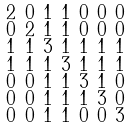<formula> <loc_0><loc_0><loc_500><loc_500>\begin{smallmatrix} 2 & 0 & 1 & 1 & 0 & 0 & 0 \\ 0 & 2 & 1 & 1 & 0 & 0 & 0 \\ 1 & 1 & 3 & 1 & 1 & 1 & 1 \\ 1 & 1 & 1 & 3 & 1 & 1 & 1 \\ 0 & 0 & 1 & 1 & 3 & 1 & 0 \\ 0 & 0 & 1 & 1 & 1 & 3 & 0 \\ 0 & 0 & 1 & 1 & 0 & 0 & 3 \end{smallmatrix}</formula> 